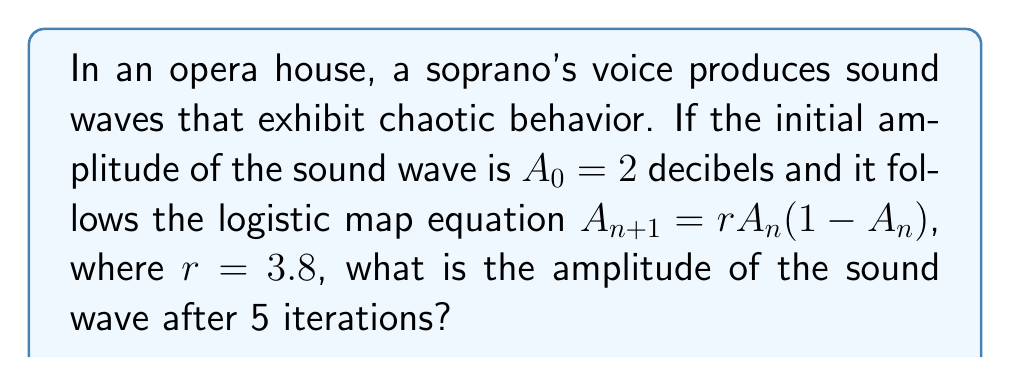What is the answer to this math problem? To solve this problem, we need to apply the logistic map equation iteratively:

1) First iteration:
   $A_1 = 3.8 \cdot 2 \cdot (1-2) = -7.6$

2) Second iteration:
   $A_2 = 3.8 \cdot (-7.6) \cdot (1-(-7.6)) = 3.8 \cdot (-7.6) \cdot 8.6 = -248.064$

3) Third iteration:
   $A_3 = 3.8 \cdot (-248.064) \cdot (1-(-248.064)) = 3.8 \cdot (-248.064) \cdot 249.064 \approx -234675.95$

4) Fourth iteration:
   $A_4 = 3.8 \cdot (-234675.95) \cdot (1-(-234675.95)) \approx 3.8 \cdot (-234675.95) \cdot 234676.95 \approx -2.09 \times 10^{11}$

5) Fifth iteration:
   $A_5 = 3.8 \cdot (-2.09 \times 10^{11}) \cdot (1-(-2.09 \times 10^{11})) \approx 3.8 \cdot (-2.09 \times 10^{11}) \cdot (2.09 \times 10^{11} + 1) \approx -1.66 \times 10^{23}$

The amplitude after 5 iterations is approximately $-1.66 \times 10^{23}$ decibels.
Answer: $-1.66 \times 10^{23}$ dB 